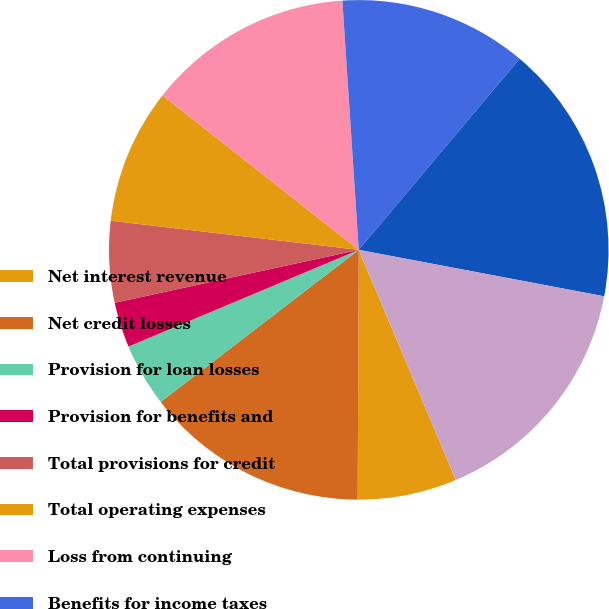Convert chart to OTSL. <chart><loc_0><loc_0><loc_500><loc_500><pie_chart><fcel>Net interest revenue<fcel>Net credit losses<fcel>Provision for loan losses<fcel>Provision for benefits and<fcel>Total provisions for credit<fcel>Total operating expenses<fcel>Loss from continuing<fcel>Benefits for income taxes<fcel>(Loss) from continuing<fcel>Citi Holdings net loss<nl><fcel>6.42%<fcel>14.51%<fcel>4.09%<fcel>2.93%<fcel>5.26%<fcel>8.75%<fcel>13.34%<fcel>12.18%<fcel>16.84%<fcel>15.67%<nl></chart> 